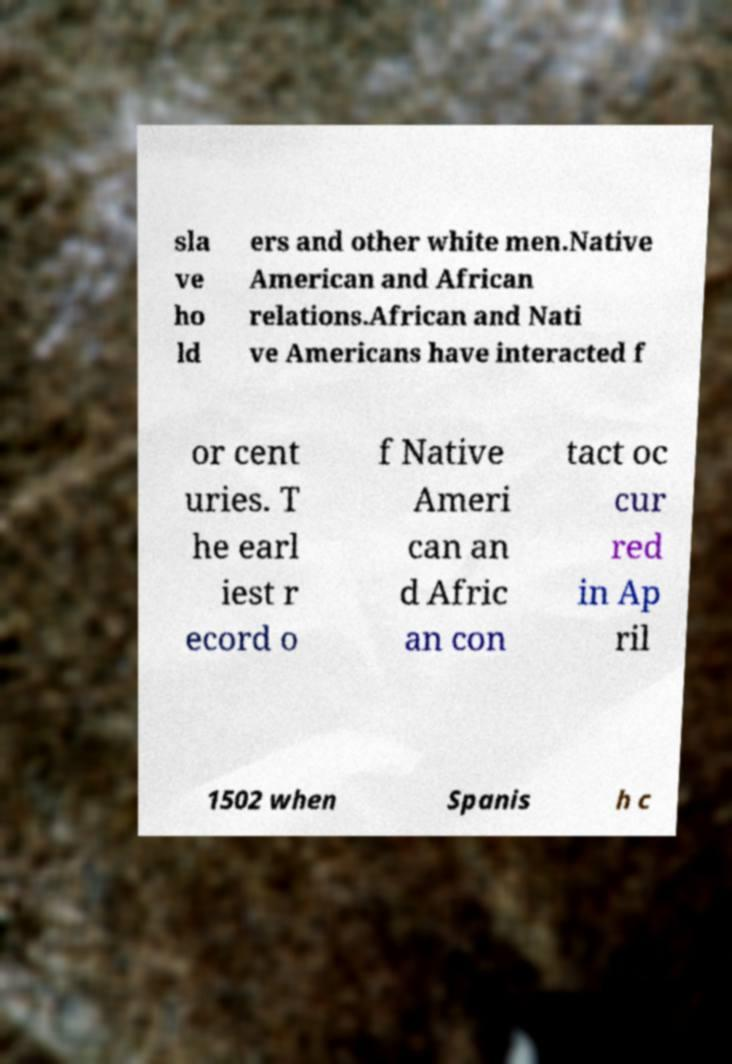Could you assist in decoding the text presented in this image and type it out clearly? sla ve ho ld ers and other white men.Native American and African relations.African and Nati ve Americans have interacted f or cent uries. T he earl iest r ecord o f Native Ameri can an d Afric an con tact oc cur red in Ap ril 1502 when Spanis h c 